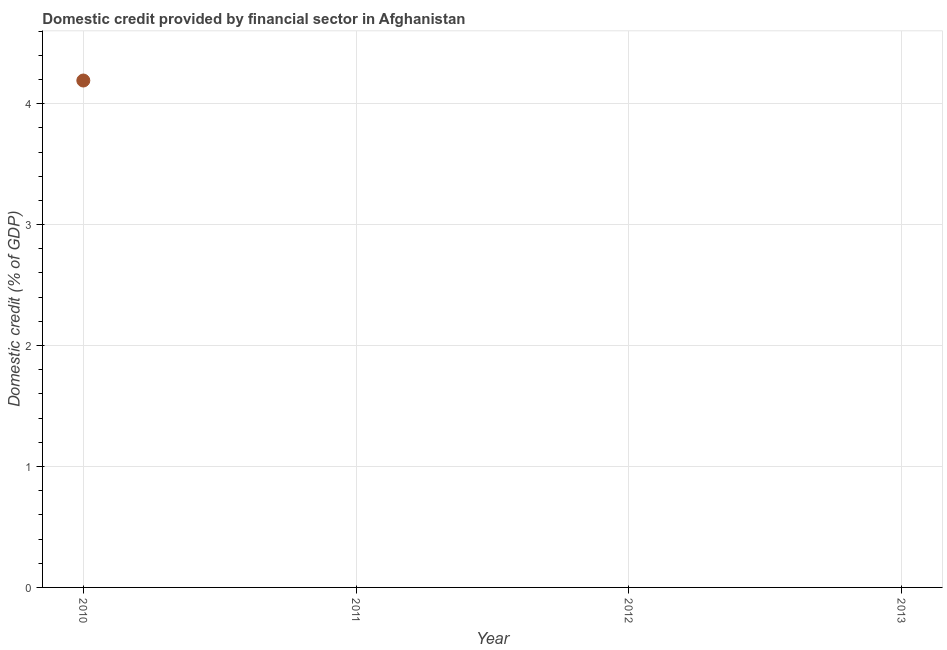Across all years, what is the maximum domestic credit provided by financial sector?
Keep it short and to the point. 4.19. In which year was the domestic credit provided by financial sector maximum?
Make the answer very short. 2010. What is the sum of the domestic credit provided by financial sector?
Offer a terse response. 4.19. What is the average domestic credit provided by financial sector per year?
Keep it short and to the point. 1.05. What is the median domestic credit provided by financial sector?
Keep it short and to the point. 0. What is the difference between the highest and the lowest domestic credit provided by financial sector?
Provide a succinct answer. 4.19. In how many years, is the domestic credit provided by financial sector greater than the average domestic credit provided by financial sector taken over all years?
Your response must be concise. 1. Does the domestic credit provided by financial sector monotonically increase over the years?
Your answer should be compact. No. How many dotlines are there?
Make the answer very short. 1. Does the graph contain any zero values?
Make the answer very short. Yes. Does the graph contain grids?
Offer a very short reply. Yes. What is the title of the graph?
Your response must be concise. Domestic credit provided by financial sector in Afghanistan. What is the label or title of the Y-axis?
Provide a short and direct response. Domestic credit (% of GDP). What is the Domestic credit (% of GDP) in 2010?
Your response must be concise. 4.19. What is the Domestic credit (% of GDP) in 2012?
Give a very brief answer. 0. What is the Domestic credit (% of GDP) in 2013?
Give a very brief answer. 0. 